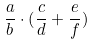<formula> <loc_0><loc_0><loc_500><loc_500>\frac { a } { b } \cdot ( \frac { c } { d } + \frac { e } { f } )</formula> 